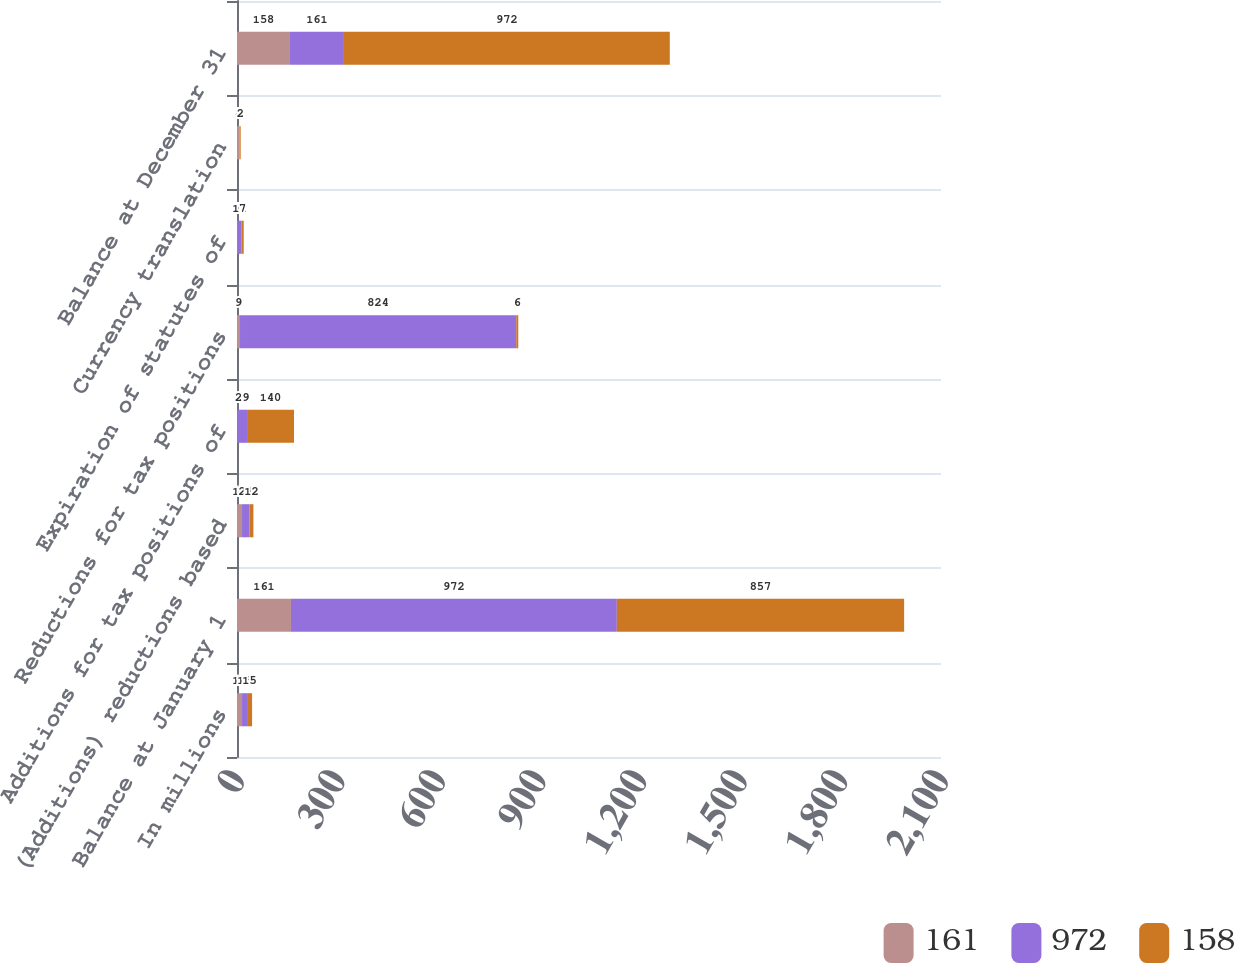Convert chart to OTSL. <chart><loc_0><loc_0><loc_500><loc_500><stacked_bar_chart><ecel><fcel>In millions<fcel>Balance at January 1<fcel>(Additions) reductions based<fcel>Additions for tax positions of<fcel>Reductions for tax positions<fcel>Expiration of statutes of<fcel>Currency translation<fcel>Balance at December 31<nl><fcel>161<fcel>15<fcel>161<fcel>15<fcel>1<fcel>9<fcel>2<fcel>8<fcel>158<nl><fcel>972<fcel>15<fcel>972<fcel>22<fcel>29<fcel>824<fcel>11<fcel>1<fcel>161<nl><fcel>158<fcel>15<fcel>857<fcel>12<fcel>140<fcel>6<fcel>7<fcel>2<fcel>972<nl></chart> 